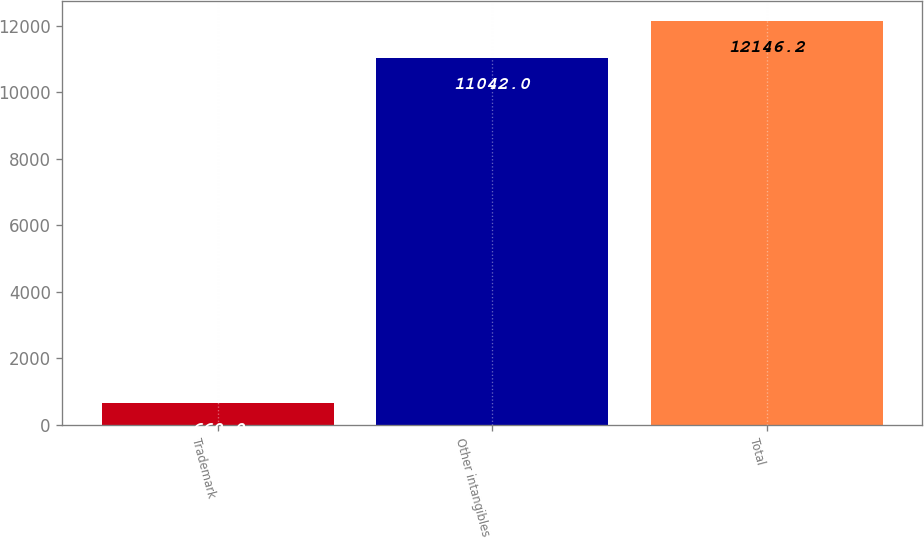<chart> <loc_0><loc_0><loc_500><loc_500><bar_chart><fcel>Trademark<fcel>Other intangibles<fcel>Total<nl><fcel>660<fcel>11042<fcel>12146.2<nl></chart> 